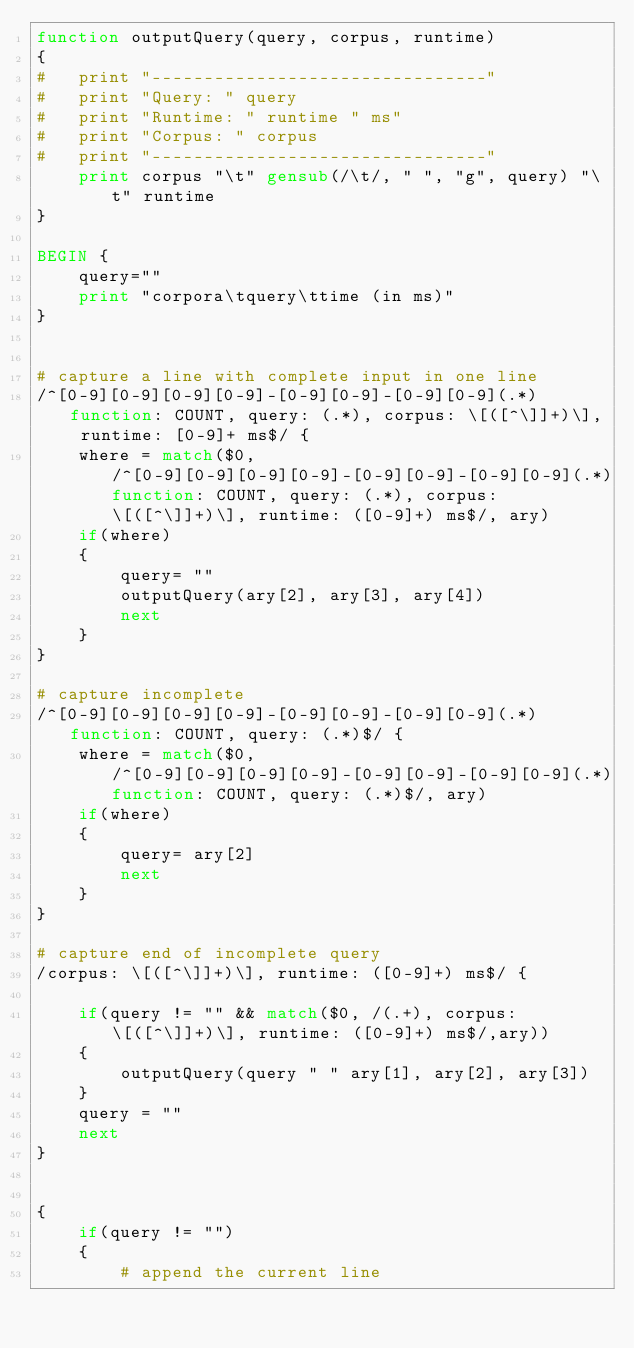<code> <loc_0><loc_0><loc_500><loc_500><_Awk_>function outputQuery(query, corpus, runtime)
{
#	print "--------------------------------"
#	print "Query: " query
#	print "Runtime: " runtime " ms"
#	print "Corpus: " corpus 
#	print "--------------------------------"
	print corpus "\t" gensub(/\t/, " ", "g", query) "\t" runtime
}

BEGIN {
	query=""
	print "corpora\tquery\ttime (in ms)"
}


# capture a line with complete input in one line
/^[0-9][0-9][0-9][0-9]-[0-9][0-9]-[0-9][0-9](.*)function: COUNT, query: (.*), corpus: \[([^\]]+)\], runtime: [0-9]+ ms$/ {
	where = match($0, /^[0-9][0-9][0-9][0-9]-[0-9][0-9]-[0-9][0-9](.*)function: COUNT, query: (.*), corpus: \[([^\]]+)\], runtime: ([0-9]+) ms$/, ary)
	if(where)
	{
		query= ""
		outputQuery(ary[2], ary[3], ary[4])
		next
	}
}

# capture incomplete
/^[0-9][0-9][0-9][0-9]-[0-9][0-9]-[0-9][0-9](.*)function: COUNT, query: (.*)$/ {
	where = match($0, /^[0-9][0-9][0-9][0-9]-[0-9][0-9]-[0-9][0-9](.*)function: COUNT, query: (.*)$/, ary)
	if(where)
	{
		query= ary[2]
		next
	}
}

# capture end of incomplete query
/corpus: \[([^\]]+)\], runtime: ([0-9]+) ms$/ {

	if(query != "" && match($0, /(.+), corpus: \[([^\]]+)\], runtime: ([0-9]+) ms$/,ary))
	{
		outputQuery(query " " ary[1], ary[2], ary[3])
	}
	query = ""
	next
}


{
	if(query != "")
	{
		# append the current line</code> 